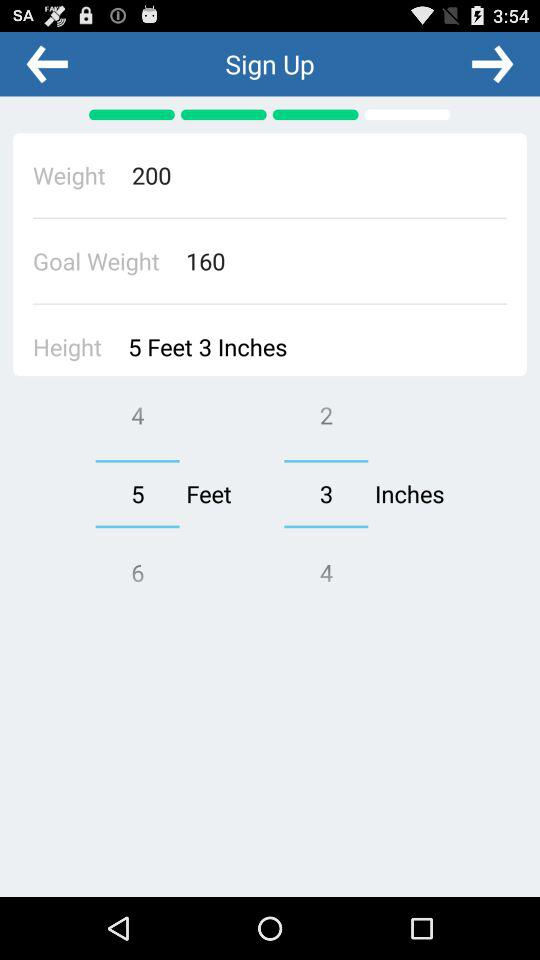What is the weight? The weight is 200. 